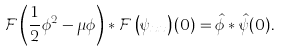Convert formula to latex. <formula><loc_0><loc_0><loc_500><loc_500>\mathcal { F } \left ( \frac { 1 } { 2 } \phi ^ { 2 } - \mu \phi \right ) * \mathcal { F } \left ( \psi _ { x x } \right ) ( 0 ) = \hat { \phi } * \hat { \psi } ( 0 ) .</formula> 